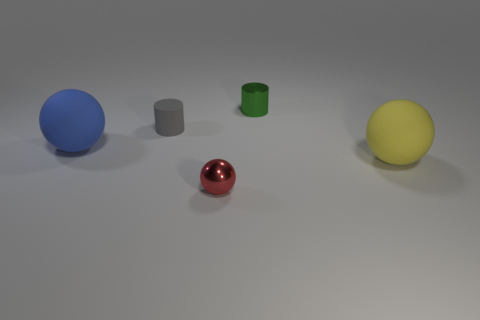Subtract all blue balls. How many balls are left? 2 Add 2 gray rubber cylinders. How many objects exist? 7 Subtract 1 cylinders. How many cylinders are left? 1 Subtract all blue balls. How many balls are left? 2 Subtract all balls. How many objects are left? 2 Subtract all purple balls. Subtract all purple cylinders. How many balls are left? 3 Add 2 tiny green shiny cylinders. How many tiny green shiny cylinders exist? 3 Subtract 1 gray cylinders. How many objects are left? 4 Subtract all small cyan metallic cylinders. Subtract all large yellow spheres. How many objects are left? 4 Add 2 rubber cylinders. How many rubber cylinders are left? 3 